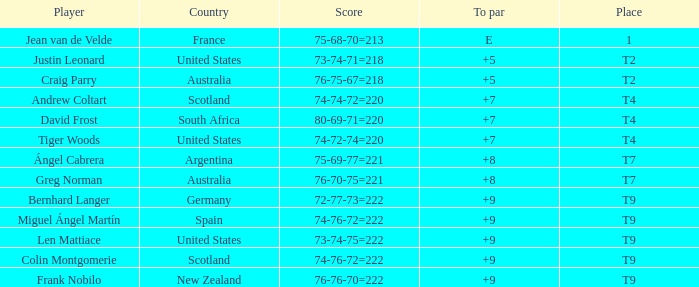Would you mind parsing the complete table? {'header': ['Player', 'Country', 'Score', 'To par', 'Place'], 'rows': [['Jean van de Velde', 'France', '75-68-70=213', 'E', '1'], ['Justin Leonard', 'United States', '73-74-71=218', '+5', 'T2'], ['Craig Parry', 'Australia', '76-75-67=218', '+5', 'T2'], ['Andrew Coltart', 'Scotland', '74-74-72=220', '+7', 'T4'], ['David Frost', 'South Africa', '80-69-71=220', '+7', 'T4'], ['Tiger Woods', 'United States', '74-72-74=220', '+7', 'T4'], ['Ángel Cabrera', 'Argentina', '75-69-77=221', '+8', 'T7'], ['Greg Norman', 'Australia', '76-70-75=221', '+8', 'T7'], ['Bernhard Langer', 'Germany', '72-77-73=222', '+9', 'T9'], ['Miguel Ángel Martín', 'Spain', '74-76-72=222', '+9', 'T9'], ['Len Mattiace', 'United States', '73-74-75=222', '+9', 'T9'], ['Colin Montgomerie', 'Scotland', '74-76-72=222', '+9', 'T9'], ['Frank Nobilo', 'New Zealand', '76-76-70=222', '+9', 'T9']]} Which player from Scotland has a To Par score of +7? Andrew Coltart. 